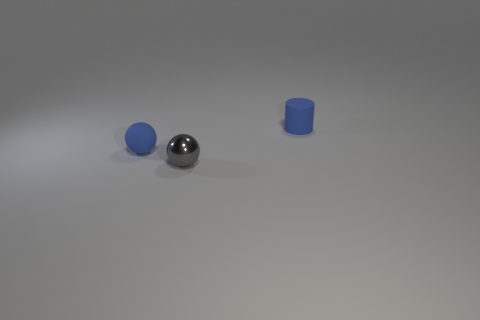Is the number of gray cylinders less than the number of metal objects?
Your answer should be compact. Yes. How big is the blue thing that is right of the blue object that is left of the tiny rubber object on the right side of the small matte ball?
Your answer should be very brief. Small. How many other things are the same color as the metal object?
Offer a very short reply. 0. Does the small shiny sphere that is to the left of the rubber cylinder have the same color as the rubber cylinder?
Give a very brief answer. No. What number of objects are either small gray blocks or tiny blue balls?
Provide a succinct answer. 1. There is a object that is in front of the blue ball; what is its color?
Keep it short and to the point. Gray. Are there fewer tiny cylinders in front of the tiny matte sphere than gray spheres?
Provide a short and direct response. Yes. What is the size of the thing that is the same color as the tiny cylinder?
Ensure brevity in your answer.  Small. Does the blue sphere have the same material as the blue cylinder?
Your answer should be compact. Yes. What number of things are either gray spheres that are left of the small cylinder or tiny objects to the left of the tiny blue matte cylinder?
Make the answer very short. 2. 